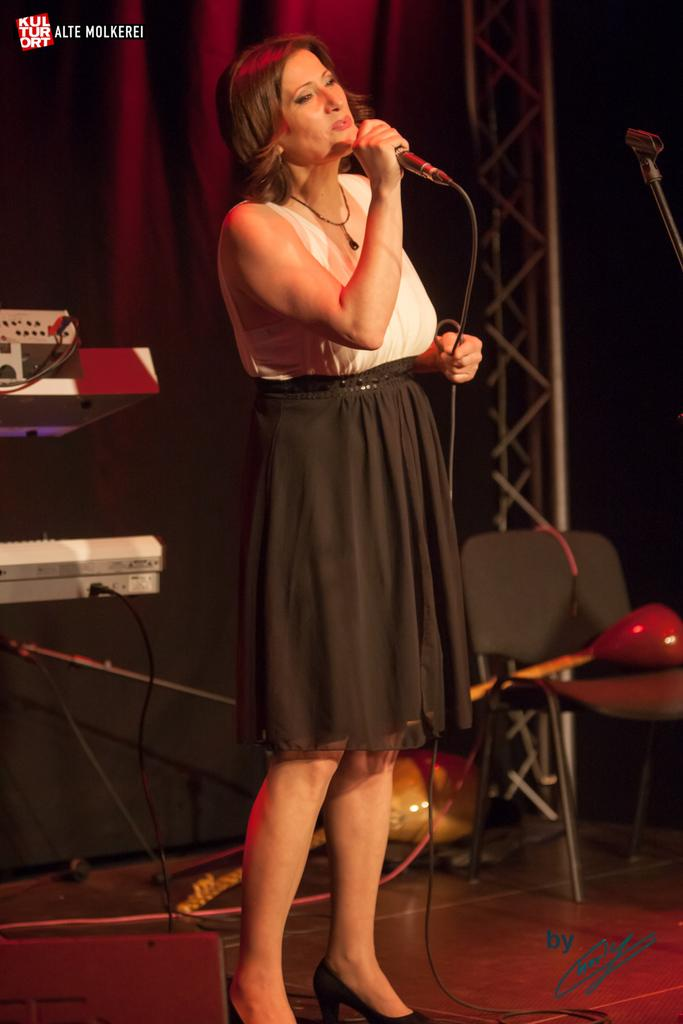What is the main subject of the image? There is a person in the image. What is the person wearing? The person is wearing a black and white dress and a white dress. What is the person holding in the image? The person is holding a microphone. Can you describe the setting of the image? There is a chair on the right side of the image, and the background of the image is black. What other objects can be seen in the image? There are groove boxes in the image. Can you see any visible veins on the person's hand while they are holding the microphone? There is no information about the person's hand or visible veins in the provided facts, so we cannot answer this question based on the image. 